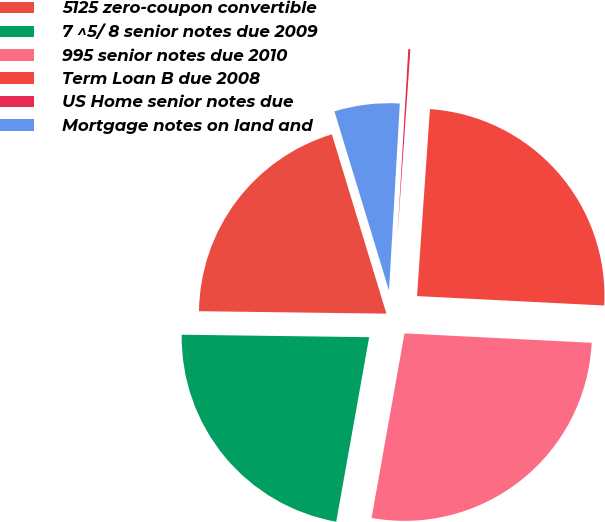<chart> <loc_0><loc_0><loc_500><loc_500><pie_chart><fcel>5125 zero-coupon convertible<fcel>7 ^5/ 8 senior notes due 2009<fcel>995 senior notes due 2010<fcel>Term Loan B due 2008<fcel>US Home senior notes due<fcel>Mortgage notes on land and<nl><fcel>20.09%<fcel>22.4%<fcel>27.01%<fcel>24.7%<fcel>0.18%<fcel>5.62%<nl></chart> 